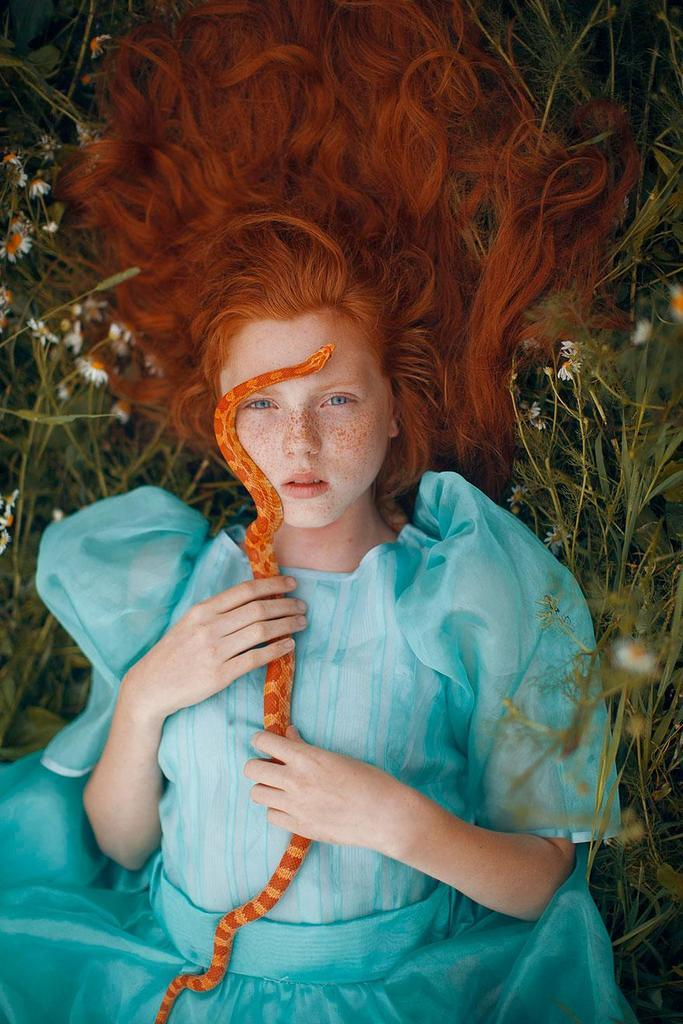Who is present in the image? There is a woman in the image. What is the woman doing in the image? The woman is lying down. What is the woman holding in the image? The woman is holding a snake. What type of vegetation can be seen in the image? There are plants with flowers on both the left and right sides of the image. What type of cork can be seen in the scene? There is no cork present in the image. What action is the woman performing with the snake? The image does not show the woman performing any action with the snake; she is simply holding it. 